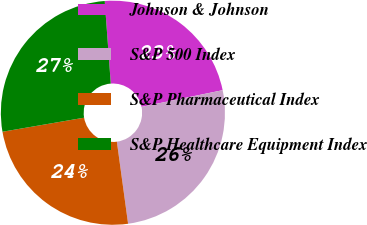Convert chart. <chart><loc_0><loc_0><loc_500><loc_500><pie_chart><fcel>Johnson & Johnson<fcel>S&P 500 Index<fcel>S&P Pharmaceutical Index<fcel>S&P Healthcare Equipment Index<nl><fcel>22.94%<fcel>26.06%<fcel>24.45%<fcel>26.55%<nl></chart> 